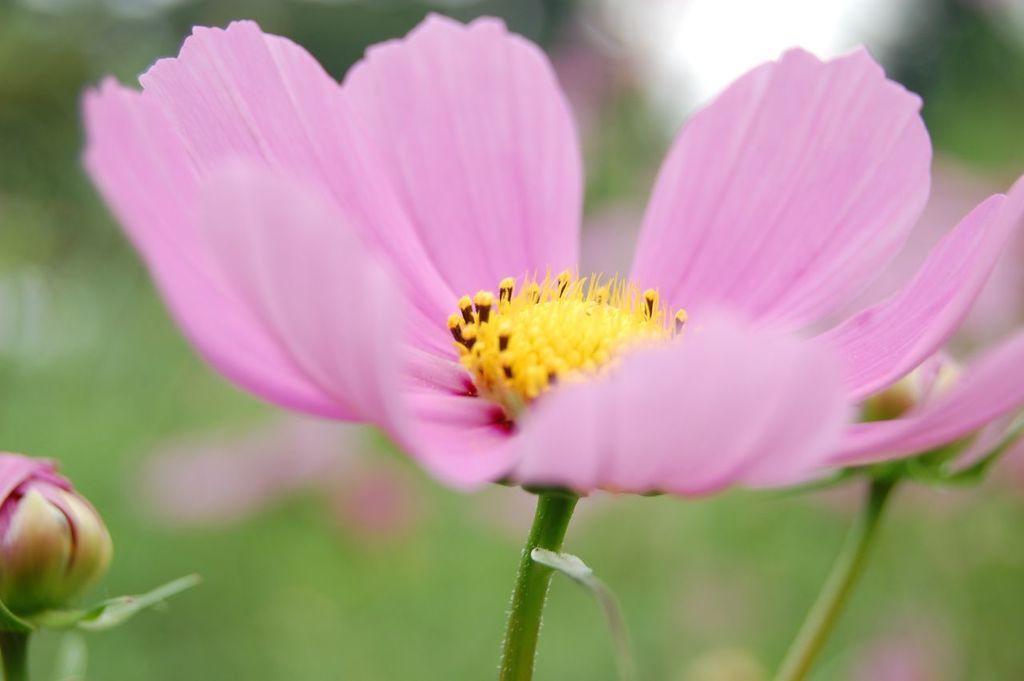What type of flower is present in the image? There is a pink color flower in the image. What other color can be seen in the image besides pink? There is a yellow color object in the image. What can be observed in the background of the image? The background of the image consists of greenery. What disease is being offered to the flower in the image? There is no disease or any indication of a disease being offered to the flower in the image. 